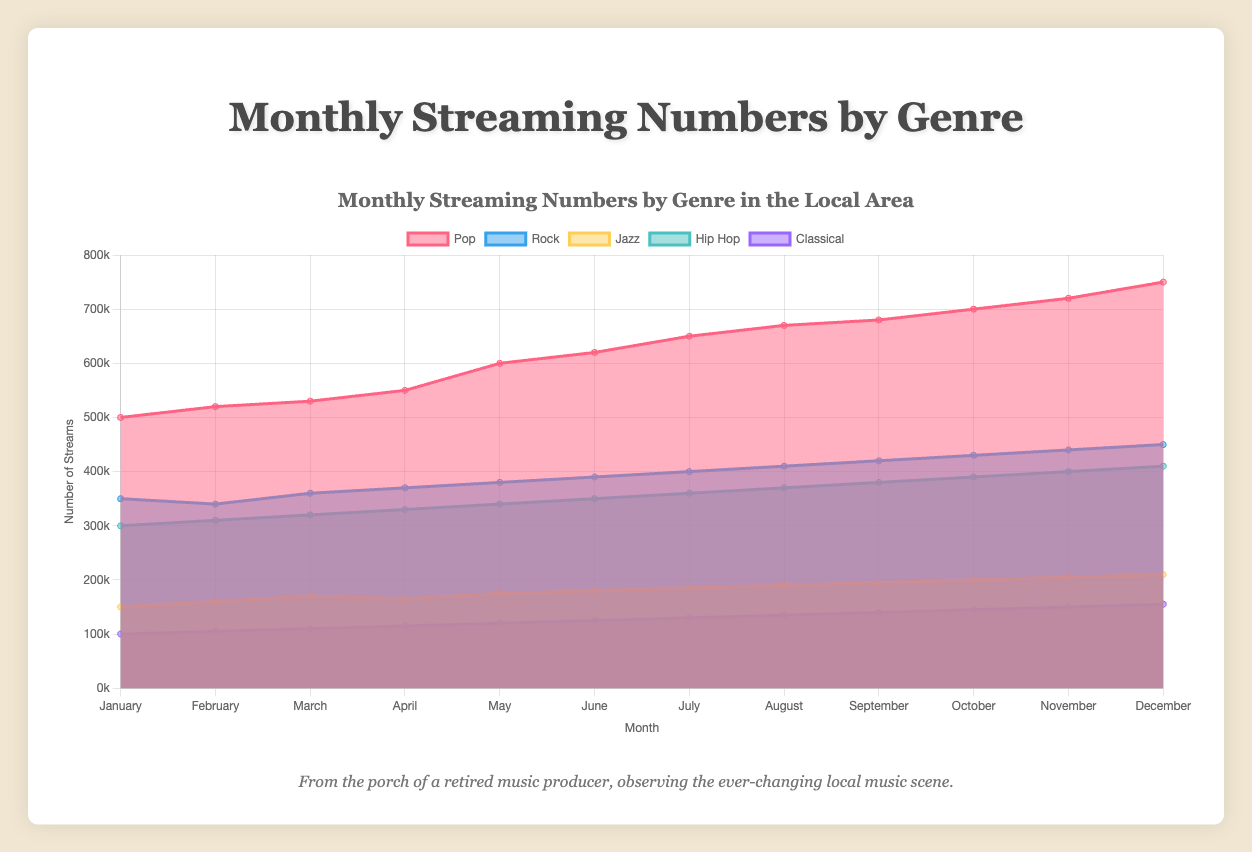What is the title of the chart? The title of the chart is displayed at the top and reads "Monthly Streaming Numbers by Genre in the Local Area".
Answer: Monthly Streaming Numbers by Genre in the Local Area What are the five genres represented in the chart? The genres are listed in the legend at the top of the chart and represented by different colors. They are "Pop", "Rock", "Jazz", "Hip Hop", and "Classical".
Answer: Pop, Rock, Jazz, Hip Hop, Classical How do the streaming numbers for Jazz in August compare to those in April? In the chart, find the streaming numbers for Jazz in both April and August. April has 165,000 streams, and August has 190,000 streams. Comparing these, we can see that August's numbers are higher.
Answer: Jazz had 25,000 more streams in August than in April Which genre has consistently seen the highest streaming numbers? By looking at the areas in the chart, the genre with the consistently largest area on top is Pop.
Answer: Pop What is the general trend in Classical music streaming numbers from January to December? Follow the line for Classical from January to December. The streaming numbers increase gradually each month.
Answer: Increasing trend What is the difference in streaming numbers for Rock music between January and December? From the chart, Rock has 350,000 streams in January and 450,000 streams in December. Compute the difference: 450,000 - 350,000.
Answer: 100,000 Which month shows the highest streaming numbers for Hip Hop? Identify the peak point for Hip Hop's line in the chart. The highest point is in December, where it reaches 410,000 streams.
Answer: December What's the combined streaming number for Pop and Rock in July? Sum the streaming numbers for Pop and Rock in July from the chart. Pop has 650,000, and Rock has 400,000, so combined: 650,000 + 400,000.
Answer: 1,050,000 How does the seasonal change appear to affect streaming numbers across all genres? Observing the overall trend lines for all genres, streaming numbers generally increase from January to December, suggesting higher engagement towards the end of the year.
Answer: Increase towards the end of the year What is the average monthly streaming number for the Classical genre? Sum the streaming numbers across all months for Classical (100,000 + 105,000 + ... + 155,000) and divide by 12 to get the average. Sum is 1,575,000, so the average is 1,575,000 / 12.
Answer: 131,250 